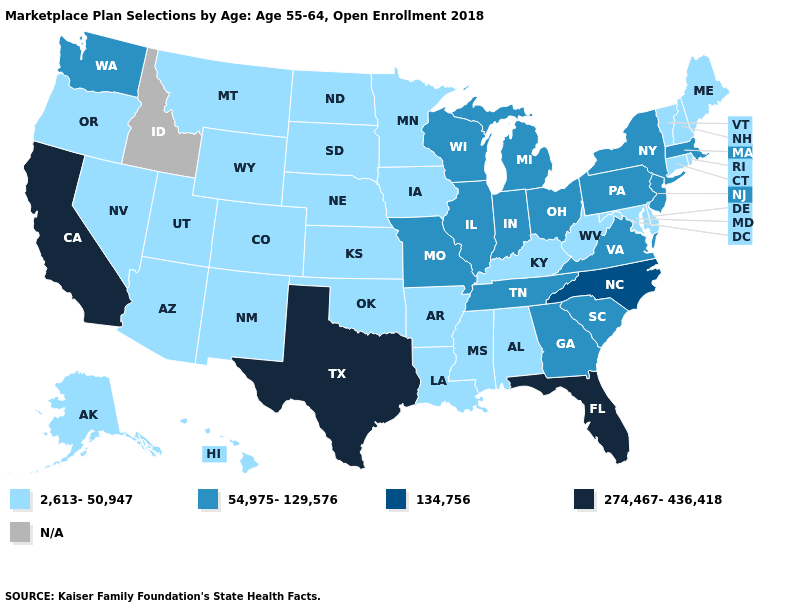What is the value of Wyoming?
Be succinct. 2,613-50,947. Among the states that border New Jersey , does Pennsylvania have the highest value?
Give a very brief answer. Yes. What is the lowest value in states that border Indiana?
Concise answer only. 2,613-50,947. Name the states that have a value in the range 2,613-50,947?
Be succinct. Alabama, Alaska, Arizona, Arkansas, Colorado, Connecticut, Delaware, Hawaii, Iowa, Kansas, Kentucky, Louisiana, Maine, Maryland, Minnesota, Mississippi, Montana, Nebraska, Nevada, New Hampshire, New Mexico, North Dakota, Oklahoma, Oregon, Rhode Island, South Dakota, Utah, Vermont, West Virginia, Wyoming. What is the value of Georgia?
Be succinct. 54,975-129,576. What is the highest value in the South ?
Give a very brief answer. 274,467-436,418. Does California have the highest value in the USA?
Write a very short answer. Yes. Which states have the lowest value in the USA?
Give a very brief answer. Alabama, Alaska, Arizona, Arkansas, Colorado, Connecticut, Delaware, Hawaii, Iowa, Kansas, Kentucky, Louisiana, Maine, Maryland, Minnesota, Mississippi, Montana, Nebraska, Nevada, New Hampshire, New Mexico, North Dakota, Oklahoma, Oregon, Rhode Island, South Dakota, Utah, Vermont, West Virginia, Wyoming. What is the highest value in the South ?
Give a very brief answer. 274,467-436,418. What is the value of California?
Be succinct. 274,467-436,418. What is the highest value in the USA?
Give a very brief answer. 274,467-436,418. Does Mississippi have the lowest value in the USA?
Write a very short answer. Yes. 